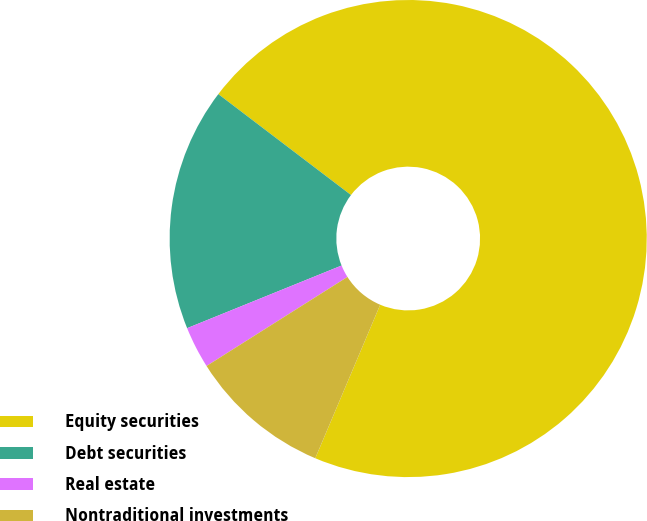Convert chart. <chart><loc_0><loc_0><loc_500><loc_500><pie_chart><fcel>Equity securities<fcel>Debt securities<fcel>Real estate<fcel>Nontraditional investments<nl><fcel>71.02%<fcel>16.48%<fcel>2.84%<fcel>9.66%<nl></chart> 